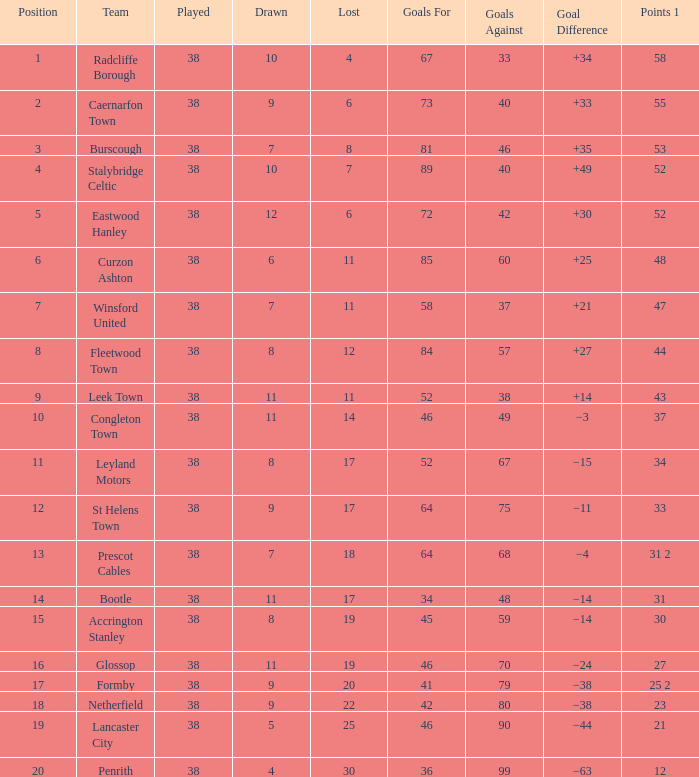What is the total when playing with point 1 of 53, and a position greater than 3? None. 